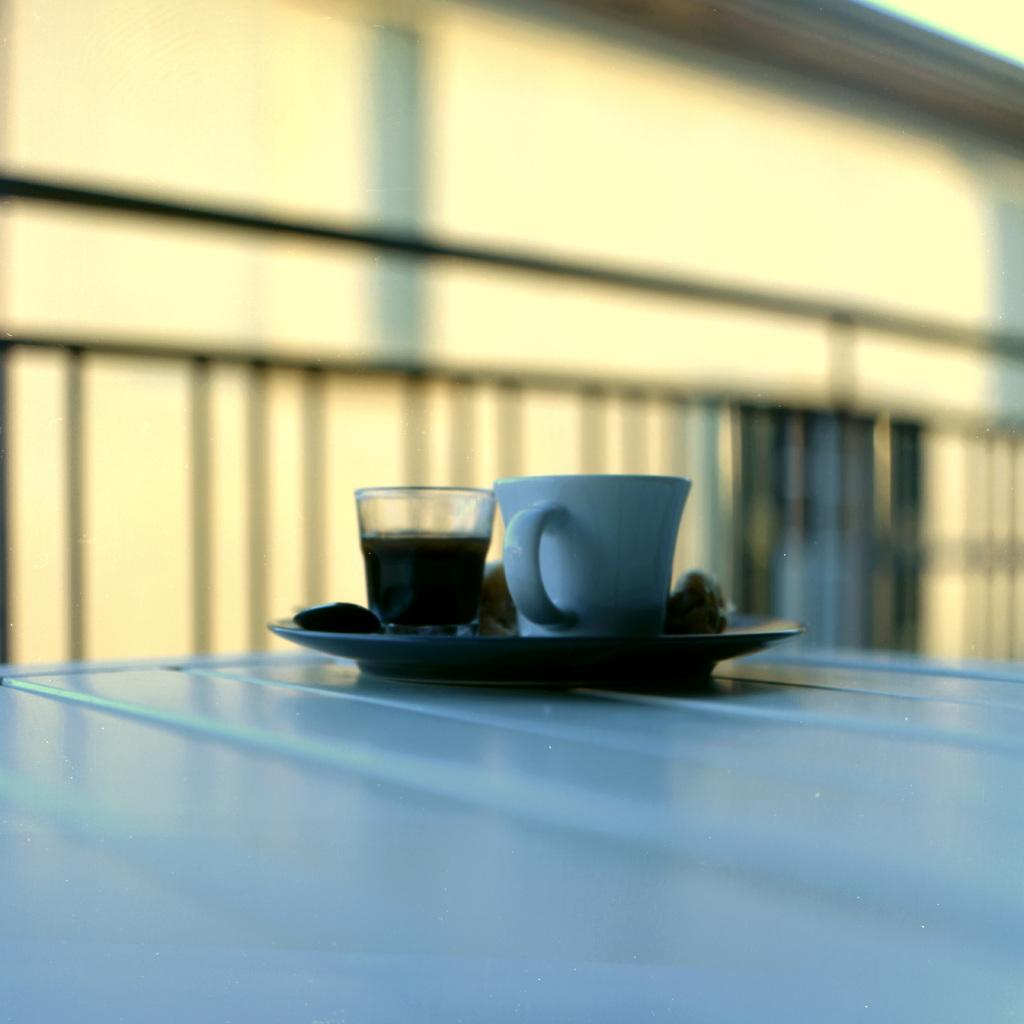What piece of furniture is present in the image? There is a table in the image. What color is the table? The table is white. What items can be seen on the table? There is a plate, a glass with a drink, and a cup on the table. What can be seen in the background of the image? There is a yellow wall in the background of the image. What is the value of the society depicted in the image? There is no society depicted in the image, as it only shows a table, plate, glass, cup, and a yellow wall in the background. 